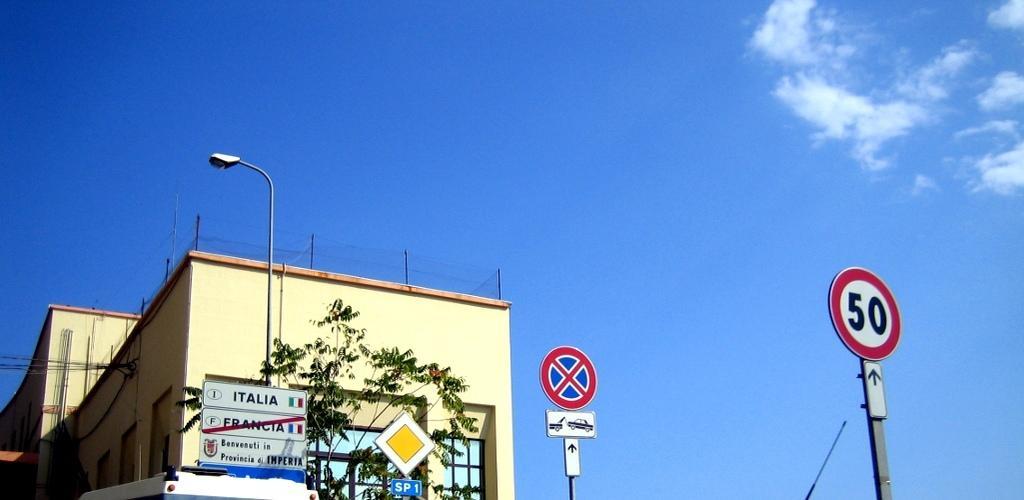Please provide a concise description of this image. In this picture we can see few sign boards, pole, light and a vehicle, in the background we can find a building, tree and clouds. 